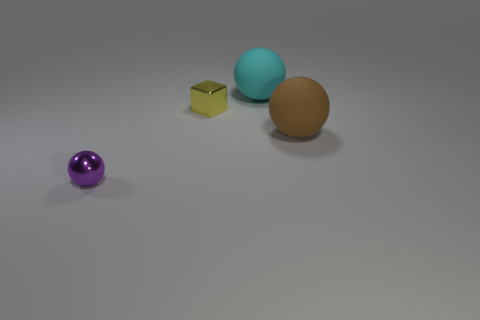Subtract all cubes. How many objects are left? 3 Subtract 2 spheres. How many spheres are left? 1 Subtract all gray blocks. Subtract all gray cylinders. How many blocks are left? 1 Subtract all purple cylinders. How many brown balls are left? 1 Subtract all cyan balls. Subtract all red matte cylinders. How many objects are left? 3 Add 4 tiny balls. How many tiny balls are left? 5 Add 1 large brown spheres. How many large brown spheres exist? 2 Add 1 purple metallic objects. How many objects exist? 5 Subtract all purple balls. How many balls are left? 2 Subtract all purple balls. How many balls are left? 2 